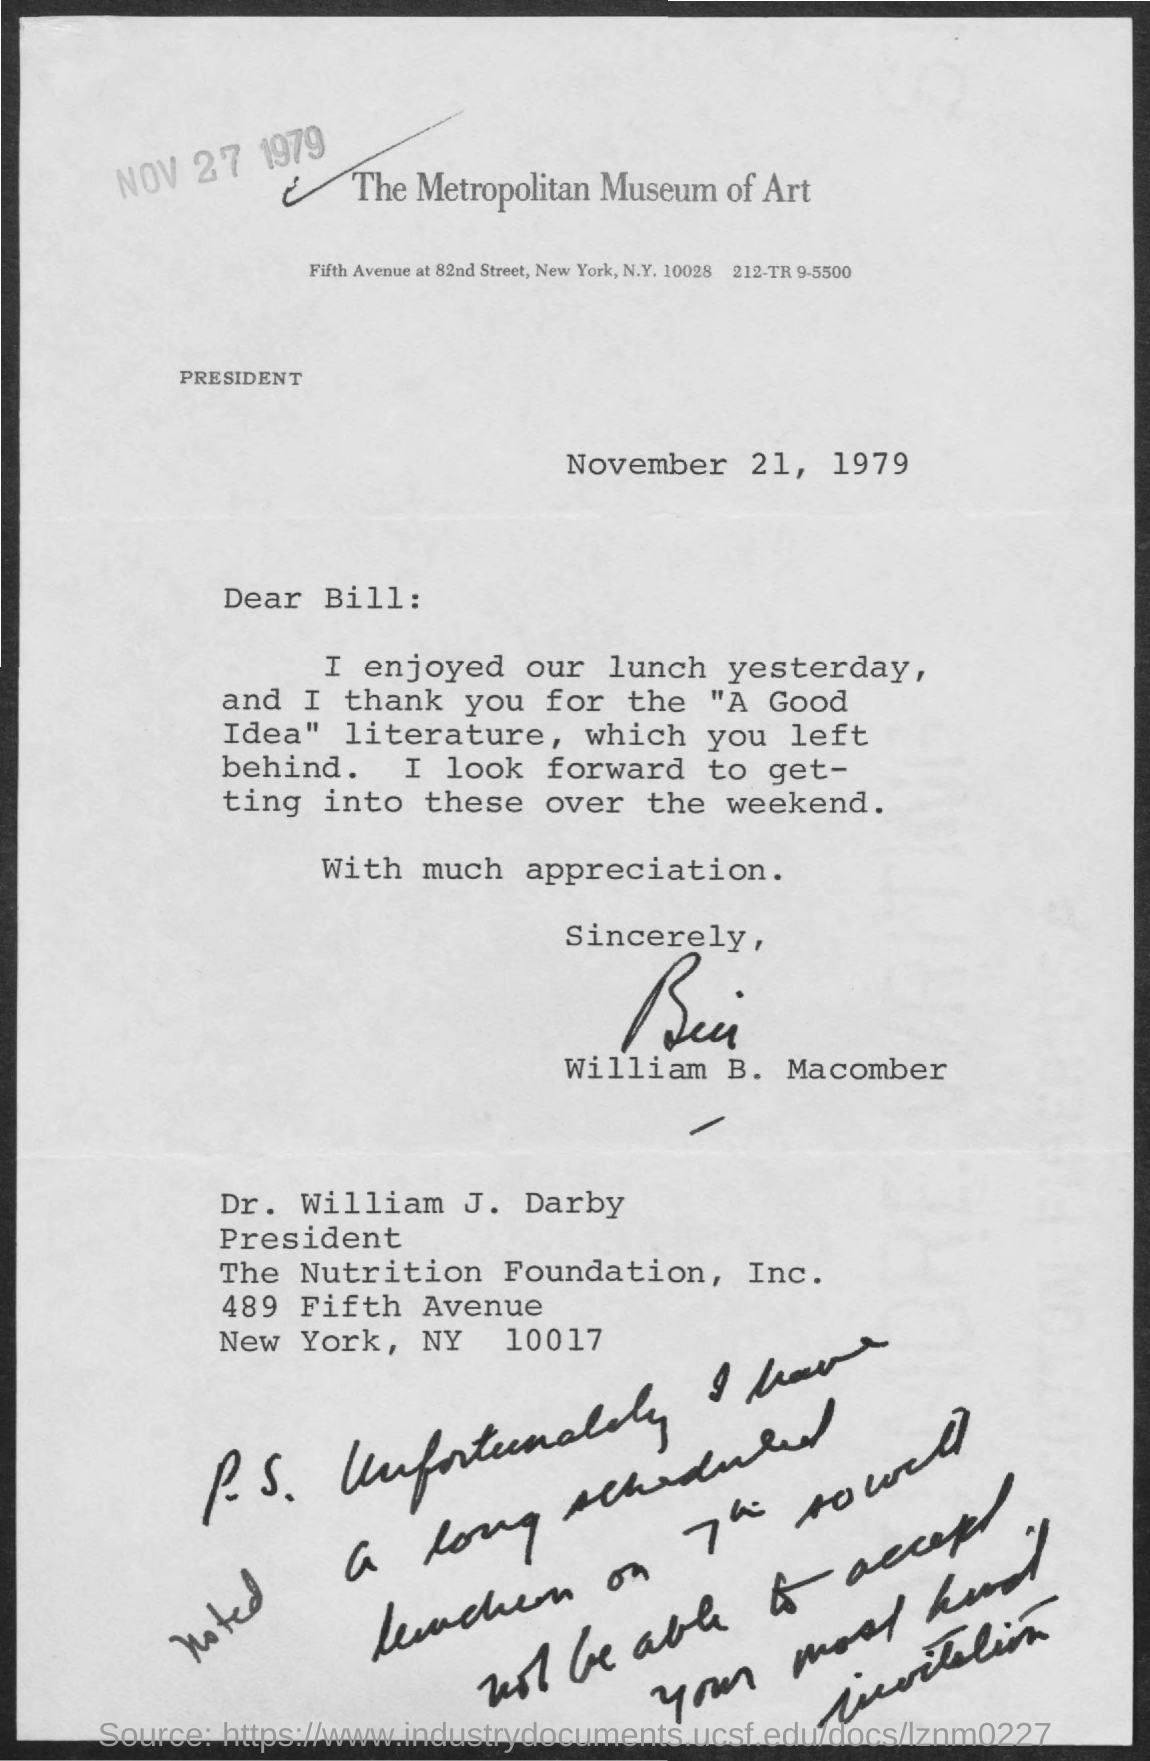Which company is mentioned in the letter head?
Ensure brevity in your answer.  The Metropolitan Museum of Art. To whom, the letter is addressed?
Your response must be concise. Dr. William J. Darby. What is the designation of Dr. William J. Darby?
Provide a short and direct response. President, The Nutrition Foundation, Inc. Who has signed this letter?
Provide a short and direct response. William b. macomber. What is the letter dated?
Ensure brevity in your answer.  November 21, 1979. 